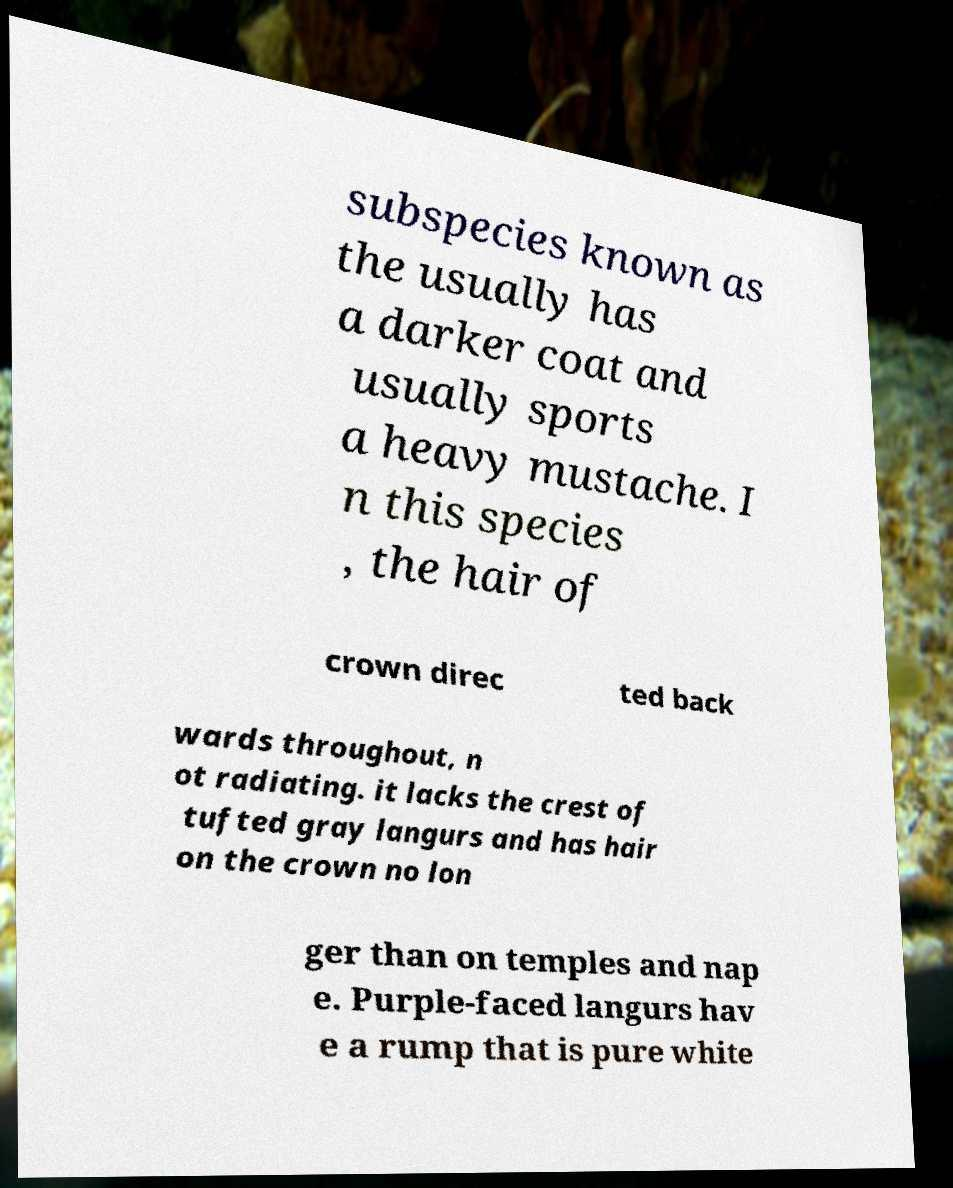Please identify and transcribe the text found in this image. subspecies known as the usually has a darker coat and usually sports a heavy mustache. I n this species , the hair of crown direc ted back wards throughout, n ot radiating. it lacks the crest of tufted gray langurs and has hair on the crown no lon ger than on temples and nap e. Purple-faced langurs hav e a rump that is pure white 